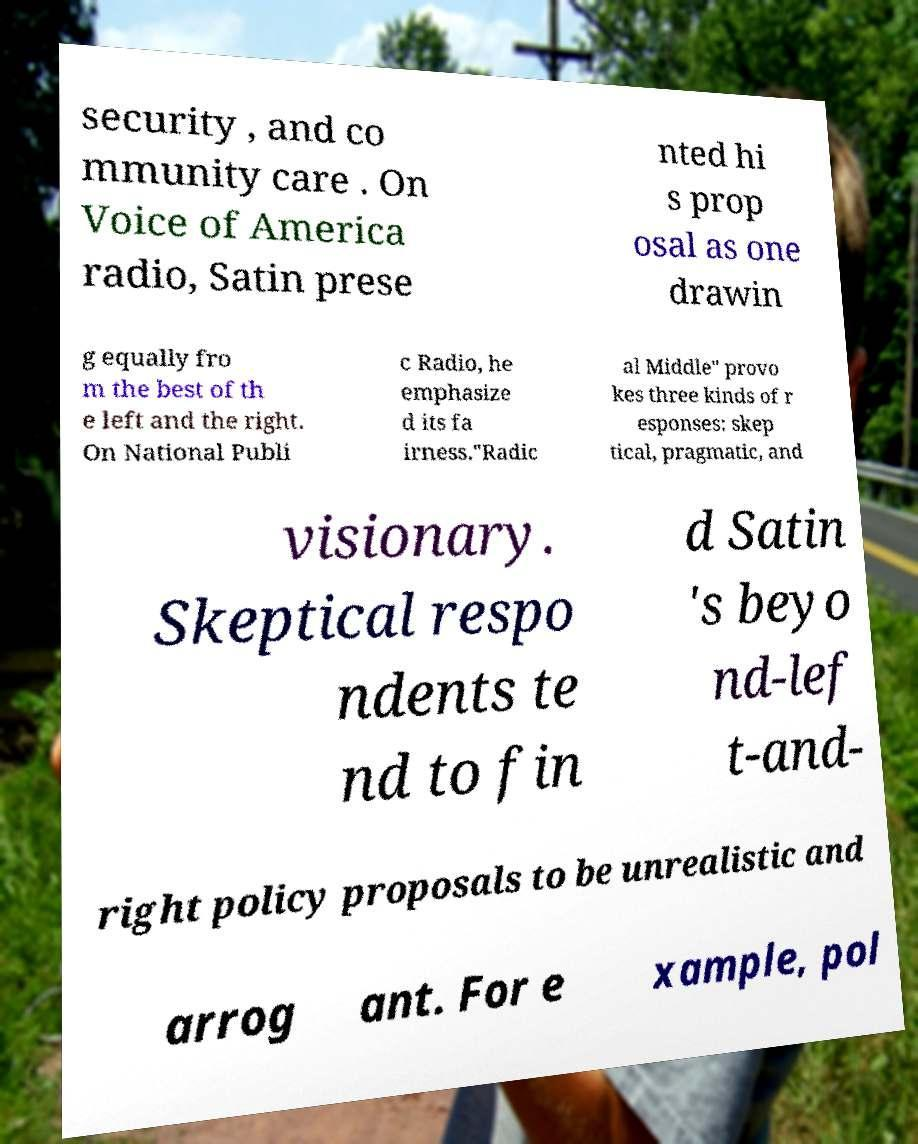For documentation purposes, I need the text within this image transcribed. Could you provide that? security , and co mmunity care . On Voice of America radio, Satin prese nted hi s prop osal as one drawin g equally fro m the best of th e left and the right. On National Publi c Radio, he emphasize d its fa irness."Radic al Middle" provo kes three kinds of r esponses: skep tical, pragmatic, and visionary. Skeptical respo ndents te nd to fin d Satin 's beyo nd-lef t-and- right policy proposals to be unrealistic and arrog ant. For e xample, pol 